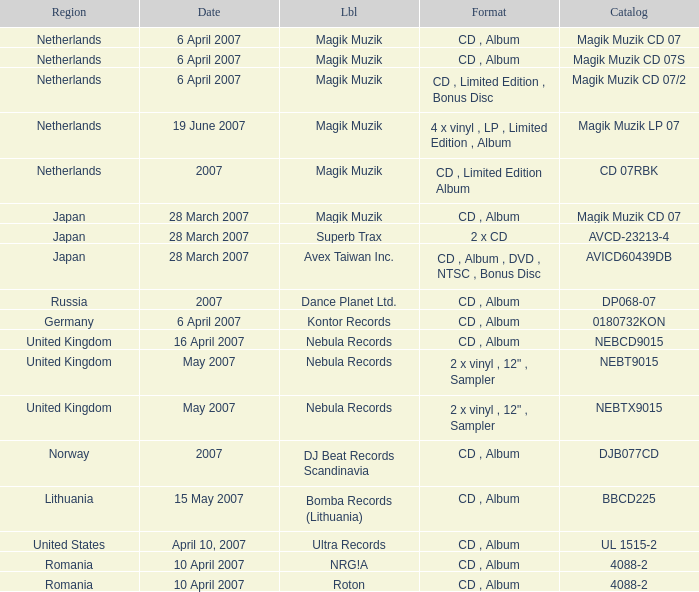For the catalog title DP068-07, what formats are available? CD , Album. Could you parse the entire table? {'header': ['Region', 'Date', 'Lbl', 'Format', 'Catalog'], 'rows': [['Netherlands', '6 April 2007', 'Magik Muzik', 'CD , Album', 'Magik Muzik CD 07'], ['Netherlands', '6 April 2007', 'Magik Muzik', 'CD , Album', 'Magik Muzik CD 07S'], ['Netherlands', '6 April 2007', 'Magik Muzik', 'CD , Limited Edition , Bonus Disc', 'Magik Muzik CD 07/2'], ['Netherlands', '19 June 2007', 'Magik Muzik', '4 x vinyl , LP , Limited Edition , Album', 'Magik Muzik LP 07'], ['Netherlands', '2007', 'Magik Muzik', 'CD , Limited Edition Album', 'CD 07RBK'], ['Japan', '28 March 2007', 'Magik Muzik', 'CD , Album', 'Magik Muzik CD 07'], ['Japan', '28 March 2007', 'Superb Trax', '2 x CD', 'AVCD-23213-4'], ['Japan', '28 March 2007', 'Avex Taiwan Inc.', 'CD , Album , DVD , NTSC , Bonus Disc', 'AVICD60439DB'], ['Russia', '2007', 'Dance Planet Ltd.', 'CD , Album', 'DP068-07'], ['Germany', '6 April 2007', 'Kontor Records', 'CD , Album', '0180732KON'], ['United Kingdom', '16 April 2007', 'Nebula Records', 'CD , Album', 'NEBCD9015'], ['United Kingdom', 'May 2007', 'Nebula Records', '2 x vinyl , 12" , Sampler', 'NEBT9015'], ['United Kingdom', 'May 2007', 'Nebula Records', '2 x vinyl , 12" , Sampler', 'NEBTX9015'], ['Norway', '2007', 'DJ Beat Records Scandinavia', 'CD , Album', 'DJB077CD'], ['Lithuania', '15 May 2007', 'Bomba Records (Lithuania)', 'CD , Album', 'BBCD225'], ['United States', 'April 10, 2007', 'Ultra Records', 'CD , Album', 'UL 1515-2'], ['Romania', '10 April 2007', 'NRG!A', 'CD , Album', '4088-2'], ['Romania', '10 April 2007', 'Roton', 'CD , Album', '4088-2']]} 